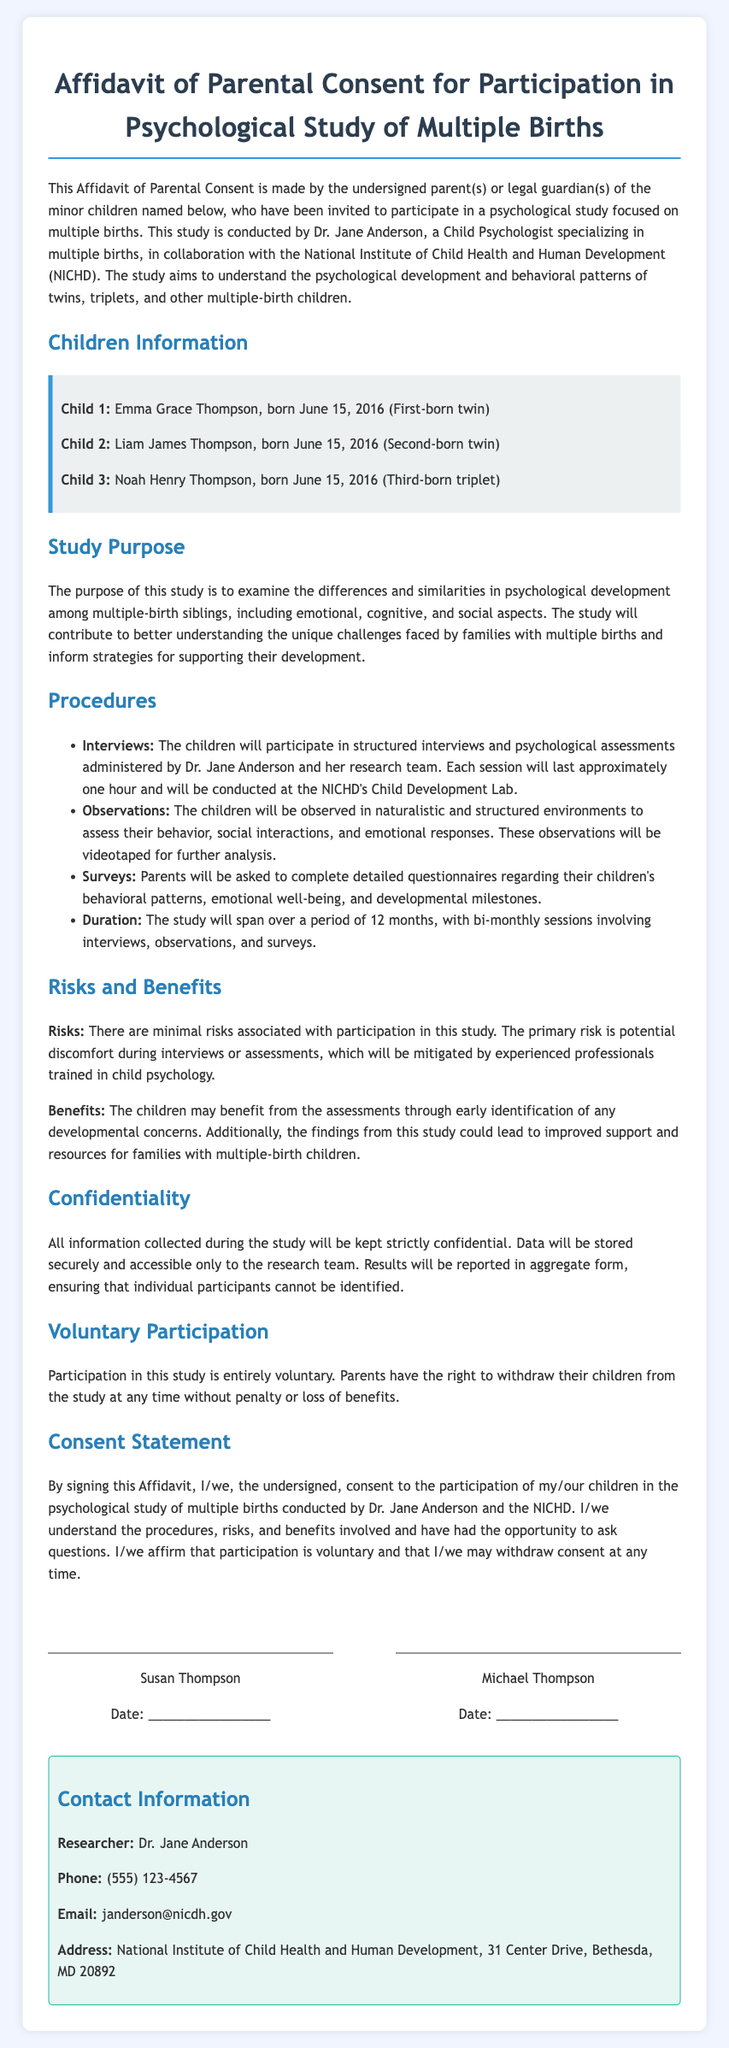What is the title of the document? The title is located at the top of the document and indicates its purpose.
Answer: Affidavit of Parental Consent for Participation in Psychological Study of Multiple Births Who is the child psychologist conducting the study? The psychologist's name is mentioned in the introductory paragraph.
Answer: Dr. Jane Anderson How many children are mentioned in the affidavit? The number of children is stated in the Children's Information section.
Answer: Three What is the birth date of the first child? The birth date is given in the children's information section.
Answer: June 15, 2016 What is the duration of the study? The duration is stated in the Procedures section.
Answer: 12 months What risks are associated with the study? Risks are described in the Risks and Benefits section of the document.
Answer: Minimal risks What is the primary purpose of the study? The purpose is explained in the Study Purpose section.
Answer: Examine psychological development Are parents allowed to withdraw their children from the study? This information is stated in the Voluntary Participation section.
Answer: Yes What is the contact phone number for Dr. Jane Anderson? The phone number is provided in the contact information section.
Answer: (555) 123-4567 Who are the signatories of the affidavit? The signatories are mentioned in the Consent Statement section.
Answer: Susan Thompson and Michael Thompson 